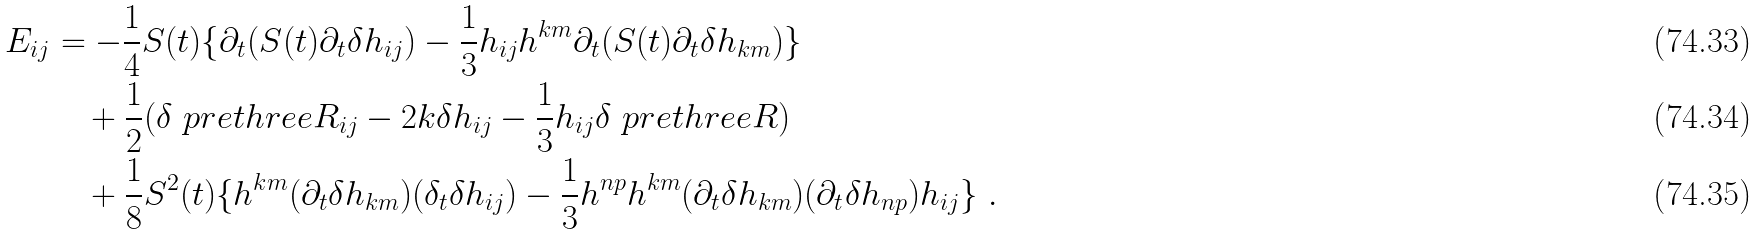Convert formula to latex. <formula><loc_0><loc_0><loc_500><loc_500>E _ { i j } & = - \frac { 1 } { 4 } S ( t ) \{ \partial _ { t } ( S ( t ) \partial _ { t } \delta h _ { i j } ) - \frac { 1 } { 3 } h _ { i j } h ^ { k m } \partial _ { t } ( S ( t ) \partial _ { t } \delta h _ { k m } ) \} \\ & \quad + \frac { 1 } { 2 } ( \delta \ p r e t h r e e R _ { i j } - 2 k \delta h _ { i j } - \frac { 1 } { 3 } h _ { i j } \delta \ p r e t h r e e R ) \\ & \quad + \frac { 1 } { 8 } S ^ { 2 } ( t ) \{ h ^ { k m } ( \partial _ { t } \delta h _ { k m } ) ( \delta _ { t } \delta h _ { i j } ) - \frac { 1 } { 3 } h ^ { n p } h ^ { k m } ( \partial _ { t } \delta h _ { k m } ) ( \partial _ { t } \delta h _ { n p } ) h _ { i j } \} \ .</formula> 